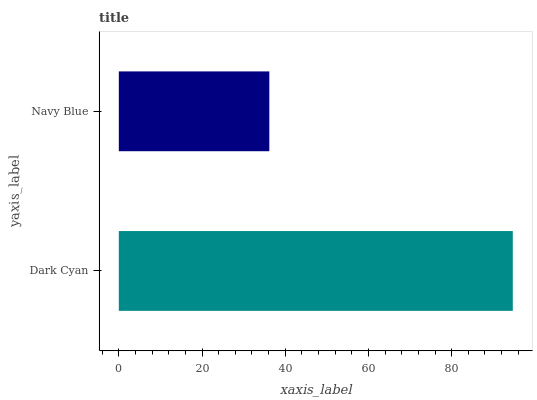Is Navy Blue the minimum?
Answer yes or no. Yes. Is Dark Cyan the maximum?
Answer yes or no. Yes. Is Navy Blue the maximum?
Answer yes or no. No. Is Dark Cyan greater than Navy Blue?
Answer yes or no. Yes. Is Navy Blue less than Dark Cyan?
Answer yes or no. Yes. Is Navy Blue greater than Dark Cyan?
Answer yes or no. No. Is Dark Cyan less than Navy Blue?
Answer yes or no. No. Is Dark Cyan the high median?
Answer yes or no. Yes. Is Navy Blue the low median?
Answer yes or no. Yes. Is Navy Blue the high median?
Answer yes or no. No. Is Dark Cyan the low median?
Answer yes or no. No. 